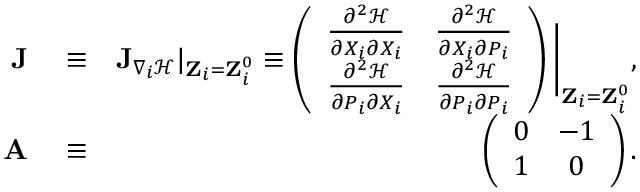<formula> <loc_0><loc_0><loc_500><loc_500>\begin{array} { r l r } { J } & \equiv } & { { J } _ { \nabla _ { i } \mathcal { H } } | _ { { Z } _ { i } = { Z } _ { i } ^ { 0 } } \equiv \left ( \begin{array} { c c } { \frac { \partial ^ { 2 } \mathcal { H } } { \partial X _ { i } \partial X _ { i } } } & { \frac { \partial ^ { 2 } \mathcal { H } } { \partial X _ { i } \partial P _ { i } } } \\ { \frac { \partial ^ { 2 } \mathcal { H } } { \partial P _ { i } \partial X _ { i } } } & { \frac { \partial ^ { 2 } \mathcal { H } } { \partial P _ { i } \partial P _ { i } } } \end{array} \right ) \Big | _ { { Z } _ { i } = { Z } _ { i } ^ { 0 } } , } \\ { A } & \equiv } & { \left ( \begin{array} { c c } { 0 } & { - 1 } \\ { 1 } & { 0 } \end{array} \right ) . } \end{array}</formula> 